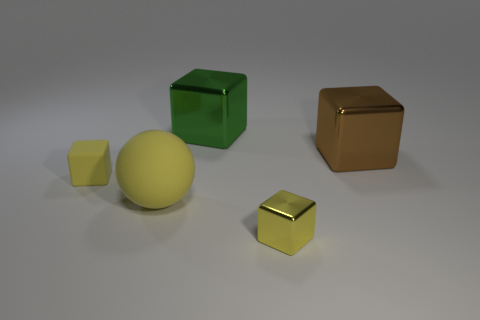What number of large things are green shiny things or blue rubber cubes?
Make the answer very short. 1. There is a green cube; is its size the same as the thing in front of the large rubber ball?
Provide a short and direct response. No. Is there any other thing that has the same shape as the green shiny object?
Keep it short and to the point. Yes. How many large yellow rubber things are there?
Ensure brevity in your answer.  1. What number of gray things are either matte cubes or small shiny blocks?
Offer a terse response. 0. Is the material of the tiny cube right of the matte ball the same as the brown block?
Your answer should be compact. Yes. How many other things are made of the same material as the brown object?
Provide a short and direct response. 2. What material is the big yellow sphere?
Provide a succinct answer. Rubber. How big is the block that is behind the brown metal cube?
Give a very brief answer. Large. There is a big object behind the big brown shiny block; what number of tiny metal cubes are on the left side of it?
Your response must be concise. 0. 